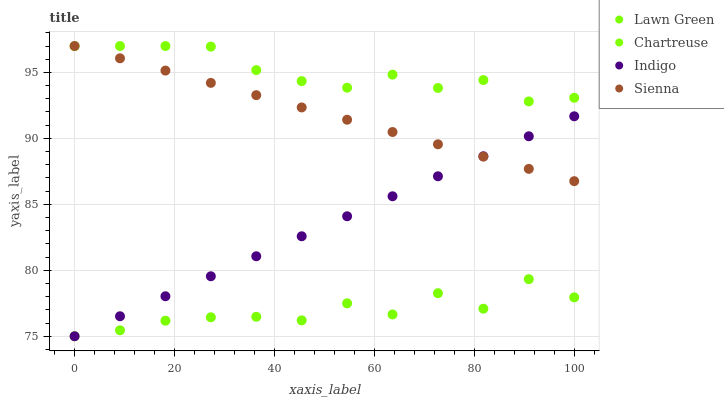Does Lawn Green have the minimum area under the curve?
Answer yes or no. Yes. Does Chartreuse have the maximum area under the curve?
Answer yes or no. Yes. Does Chartreuse have the minimum area under the curve?
Answer yes or no. No. Does Lawn Green have the maximum area under the curve?
Answer yes or no. No. Is Indigo the smoothest?
Answer yes or no. Yes. Is Lawn Green the roughest?
Answer yes or no. Yes. Is Chartreuse the smoothest?
Answer yes or no. No. Is Chartreuse the roughest?
Answer yes or no. No. Does Lawn Green have the lowest value?
Answer yes or no. Yes. Does Chartreuse have the lowest value?
Answer yes or no. No. Does Chartreuse have the highest value?
Answer yes or no. Yes. Does Lawn Green have the highest value?
Answer yes or no. No. Is Lawn Green less than Sienna?
Answer yes or no. Yes. Is Sienna greater than Lawn Green?
Answer yes or no. Yes. Does Sienna intersect Indigo?
Answer yes or no. Yes. Is Sienna less than Indigo?
Answer yes or no. No. Is Sienna greater than Indigo?
Answer yes or no. No. Does Lawn Green intersect Sienna?
Answer yes or no. No. 